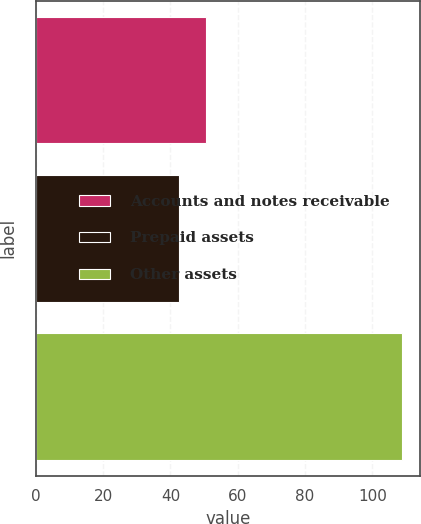<chart> <loc_0><loc_0><loc_500><loc_500><bar_chart><fcel>Accounts and notes receivable<fcel>Prepaid assets<fcel>Other assets<nl><fcel>50.7<fcel>42.5<fcel>108.7<nl></chart> 